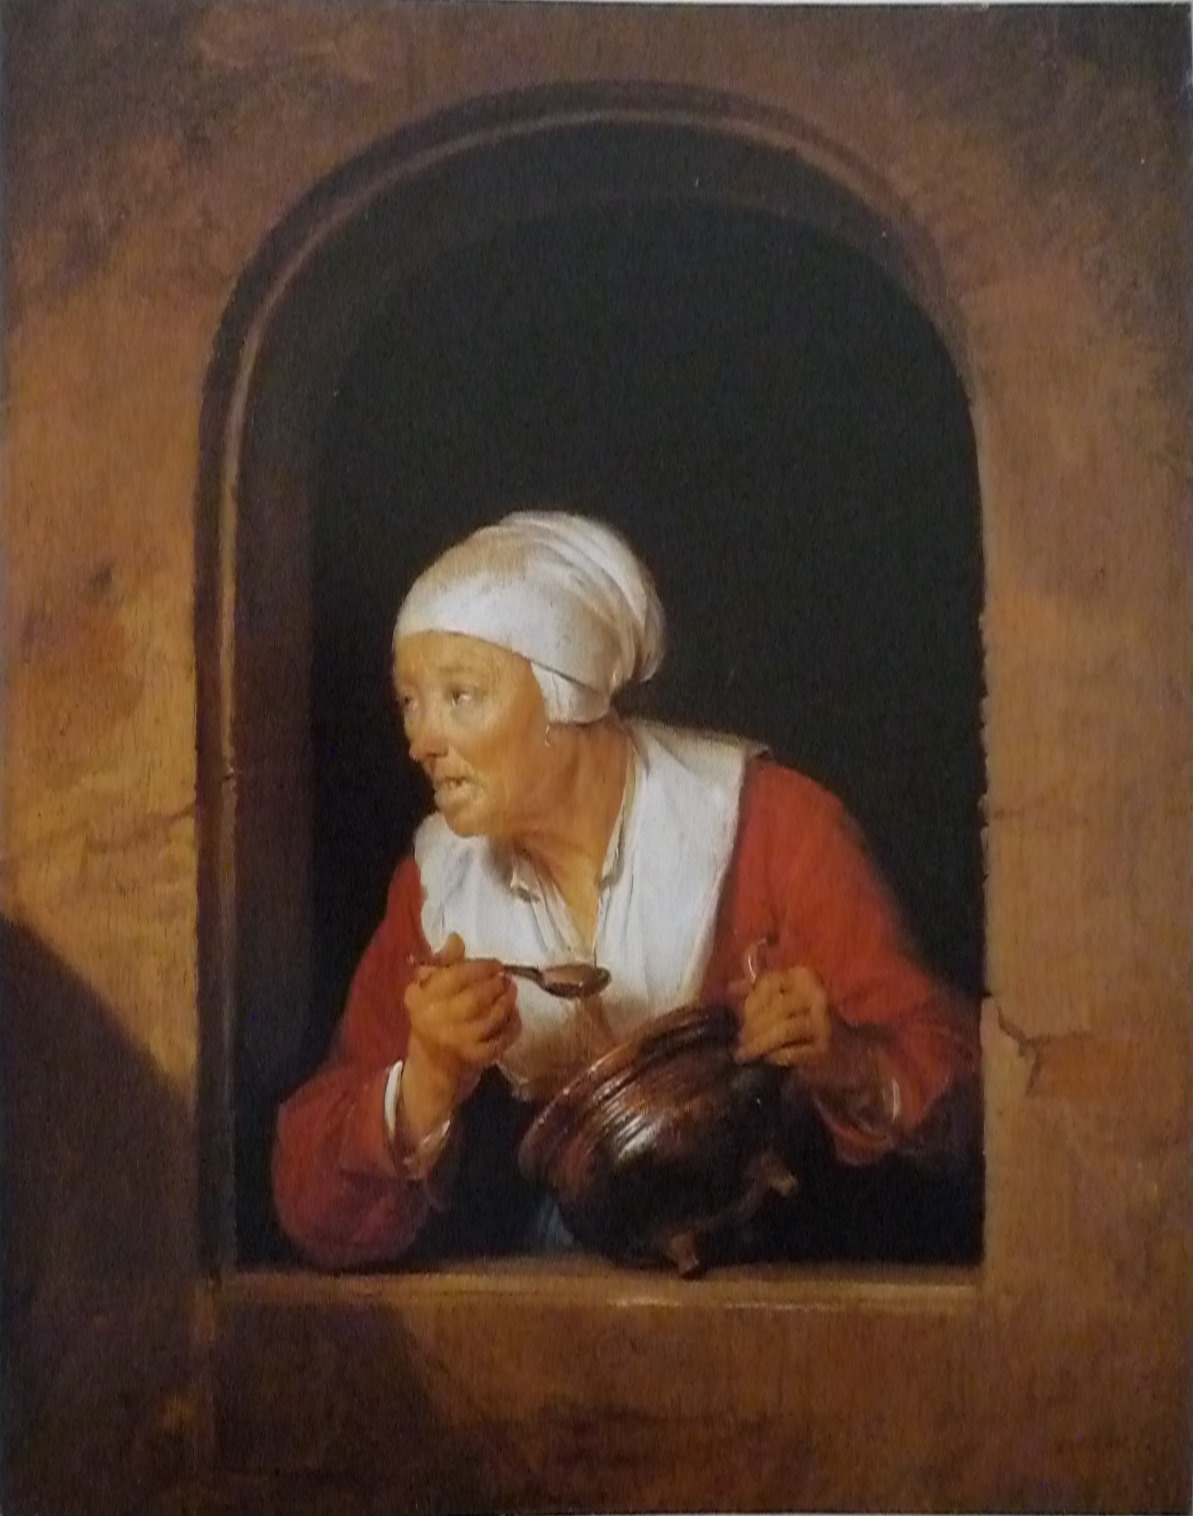Pretend you are the woman in the painting. Write a monologue of your thoughts as you lean out of the window. What could that noise be? It's rather unusual at this hour. Perhaps it's just the children playing their mischief, but it sounded much closer this time. My soup is almost ready; I can't let it burn now. The jug feels reassuring in my hands, a familiar weight amidst this sudden confusion. Maybe I should call out, but what if it's someone who means harm? Oh, I wish Albert were here. I'll just keep an eye out for now and hope it's nothing serious. Just a gust of wind, I pray. 